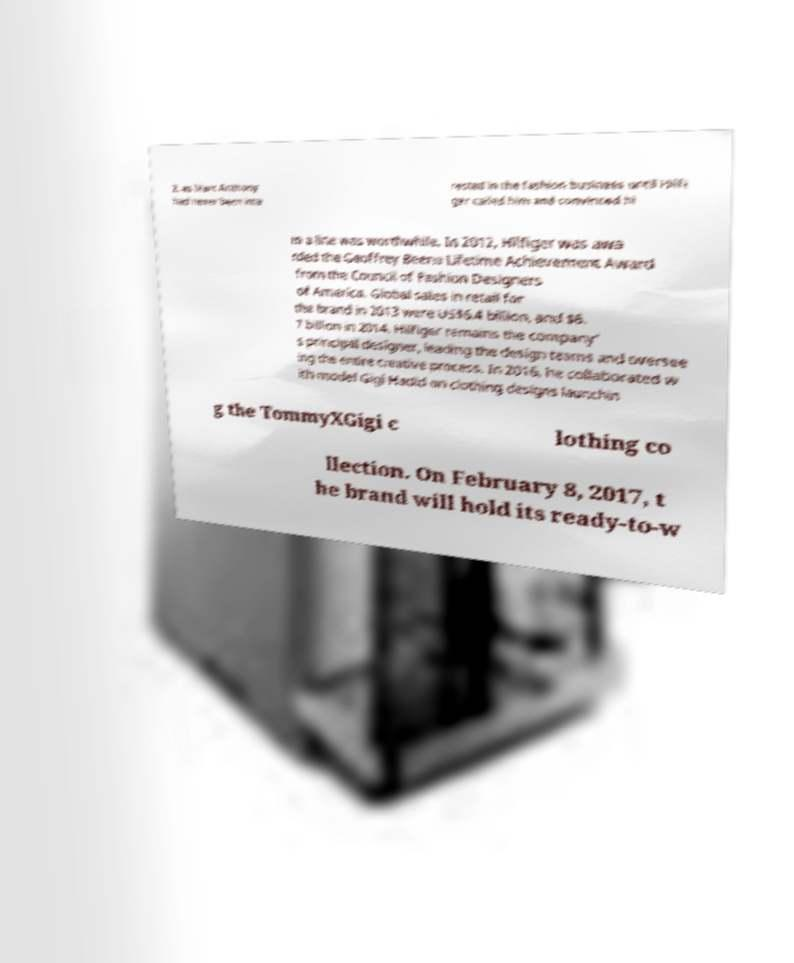Please read and relay the text visible in this image. What does it say? 2, as Marc Anthony had never been inte rested in the fashion business until Hilfi ger called him and convinced hi m a line was worthwhile. In 2012, Hilfiger was awa rded the Geoffrey Beene Lifetime Achievement Award from the Council of Fashion Designers of America. Global sales in retail for the brand in 2013 were US$6.4 billion, and $6. 7 billion in 2014. Hilfiger remains the company' s principal designer, leading the design teams and oversee ing the entire creative process. In 2016, he collaborated w ith model Gigi Hadid on clothing designs launchin g the TommyXGigi c lothing co llection. On February 8, 2017, t he brand will hold its ready-to-w 